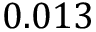Convert formula to latex. <formula><loc_0><loc_0><loc_500><loc_500>0 . 0 1 3</formula> 